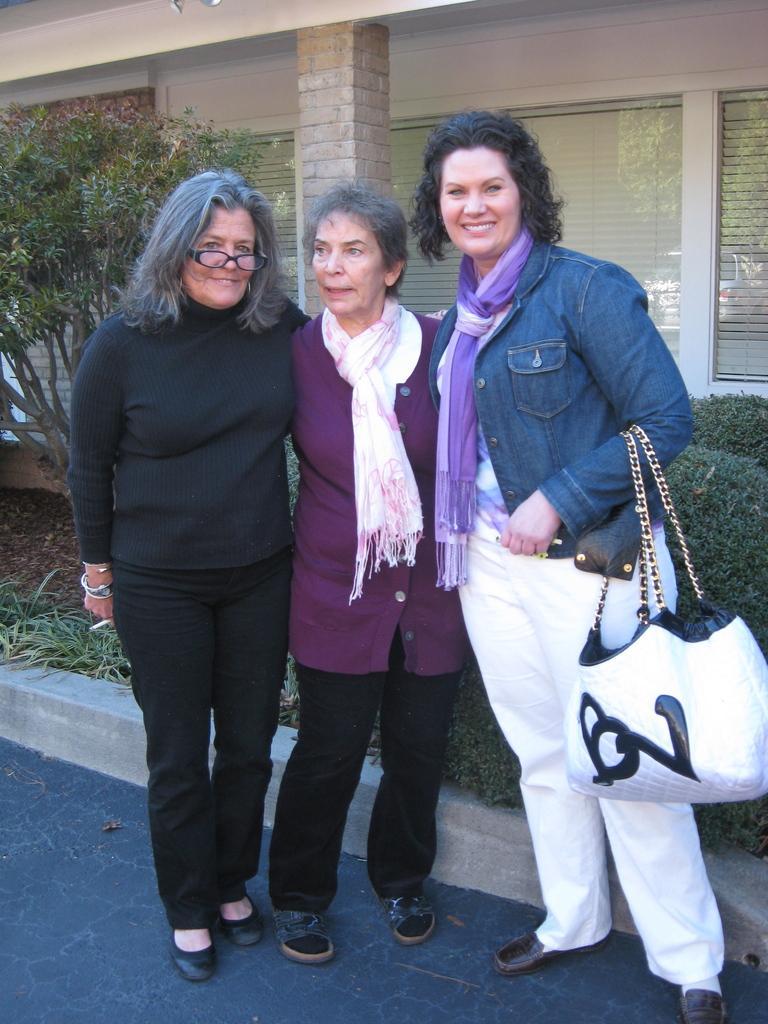Could you give a brief overview of what you see in this image? There are three women in different color dresses, smiling and standing on the road. In the background, there are plants and grass on the ground and there is a building which is having glass windows and a pillar. 